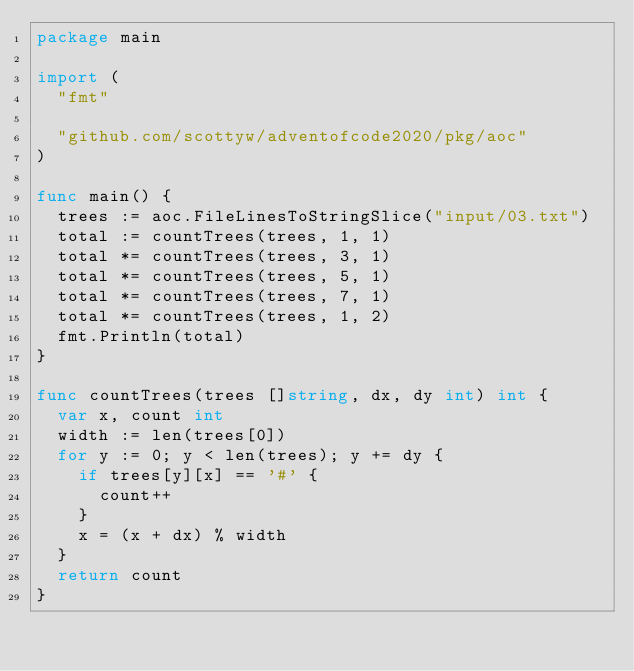Convert code to text. <code><loc_0><loc_0><loc_500><loc_500><_Go_>package main

import (
	"fmt"

	"github.com/scottyw/adventofcode2020/pkg/aoc"
)

func main() {
	trees := aoc.FileLinesToStringSlice("input/03.txt")
	total := countTrees(trees, 1, 1)
	total *= countTrees(trees, 3, 1)
	total *= countTrees(trees, 5, 1)
	total *= countTrees(trees, 7, 1)
	total *= countTrees(trees, 1, 2)
	fmt.Println(total)
}

func countTrees(trees []string, dx, dy int) int {
	var x, count int
	width := len(trees[0])
	for y := 0; y < len(trees); y += dy {
		if trees[y][x] == '#' {
			count++
		}
		x = (x + dx) % width
	}
	return count
}
</code> 